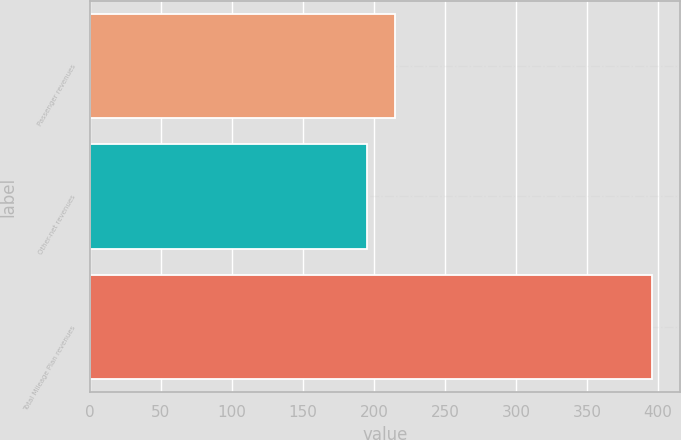Convert chart to OTSL. <chart><loc_0><loc_0><loc_500><loc_500><bar_chart><fcel>Passenger revenues<fcel>Other-net revenues<fcel>Total Mileage Plan revenues<nl><fcel>214.97<fcel>194.9<fcel>395.6<nl></chart> 